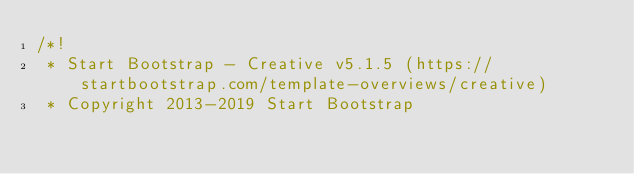Convert code to text. <code><loc_0><loc_0><loc_500><loc_500><_CSS_>/*!
 * Start Bootstrap - Creative v5.1.5 (https://startbootstrap.com/template-overviews/creative)
 * Copyright 2013-2019 Start Bootstrap</code> 